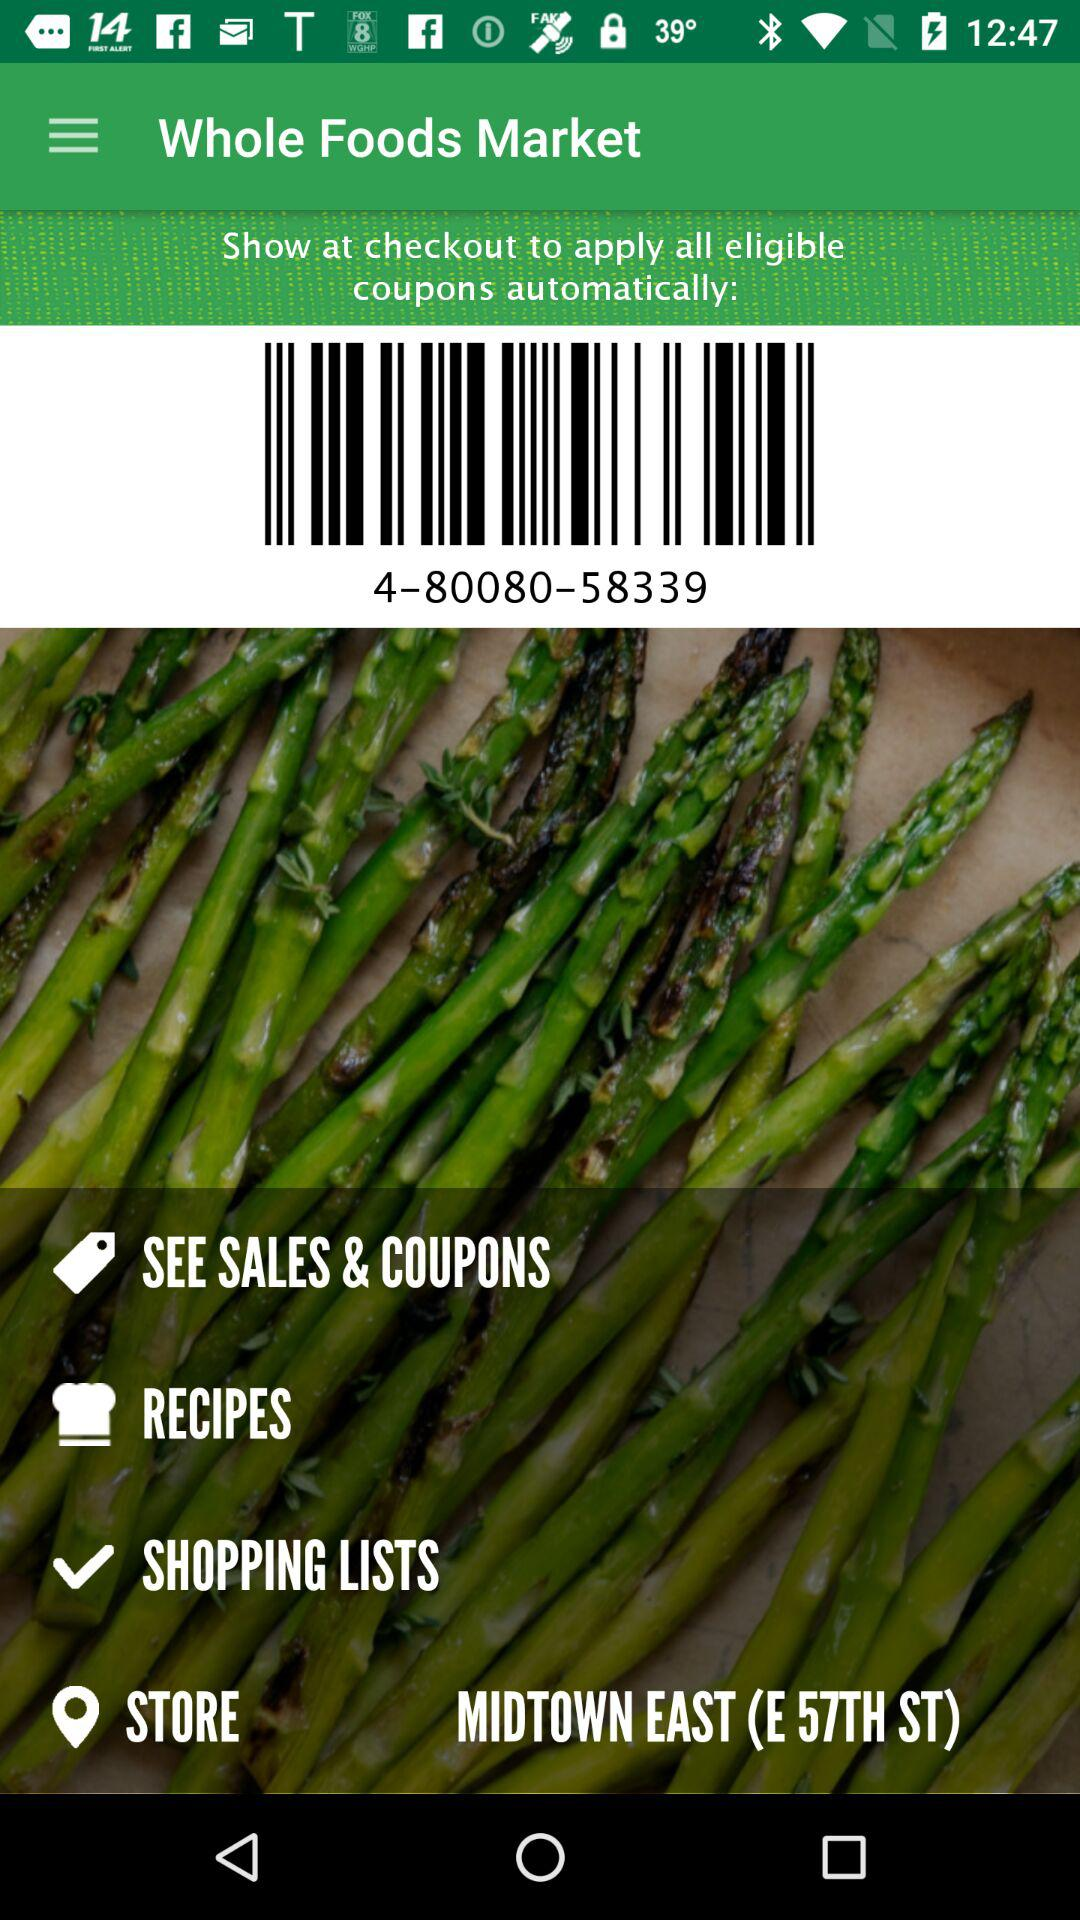What is the store location? The store location is Midtown East (E 57th St.). 